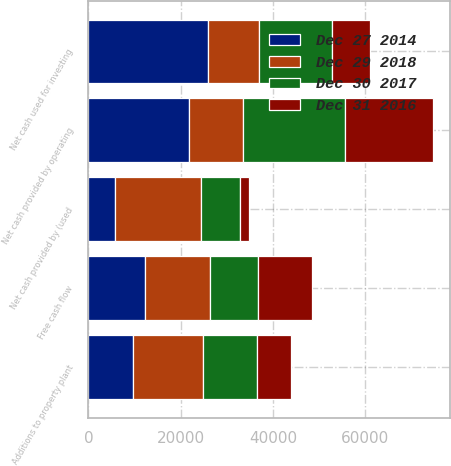Convert chart. <chart><loc_0><loc_0><loc_500><loc_500><stacked_bar_chart><ecel><fcel>Net cash provided by operating<fcel>Additions to property plant<fcel>Free cash flow<fcel>Net cash used for investing<fcel>Net cash provided by (used<nl><fcel>Dec 29 2018<fcel>11778<fcel>15181<fcel>14251<fcel>11239<fcel>18607<nl><fcel>Dec 30 2017<fcel>22110<fcel>11778<fcel>10332<fcel>15762<fcel>8475<nl><fcel>Dec 27 2014<fcel>21808<fcel>9625<fcel>12183<fcel>25817<fcel>5739<nl><fcel>Dec 31 2016<fcel>19018<fcel>7326<fcel>11692<fcel>8183<fcel>1912<nl></chart> 